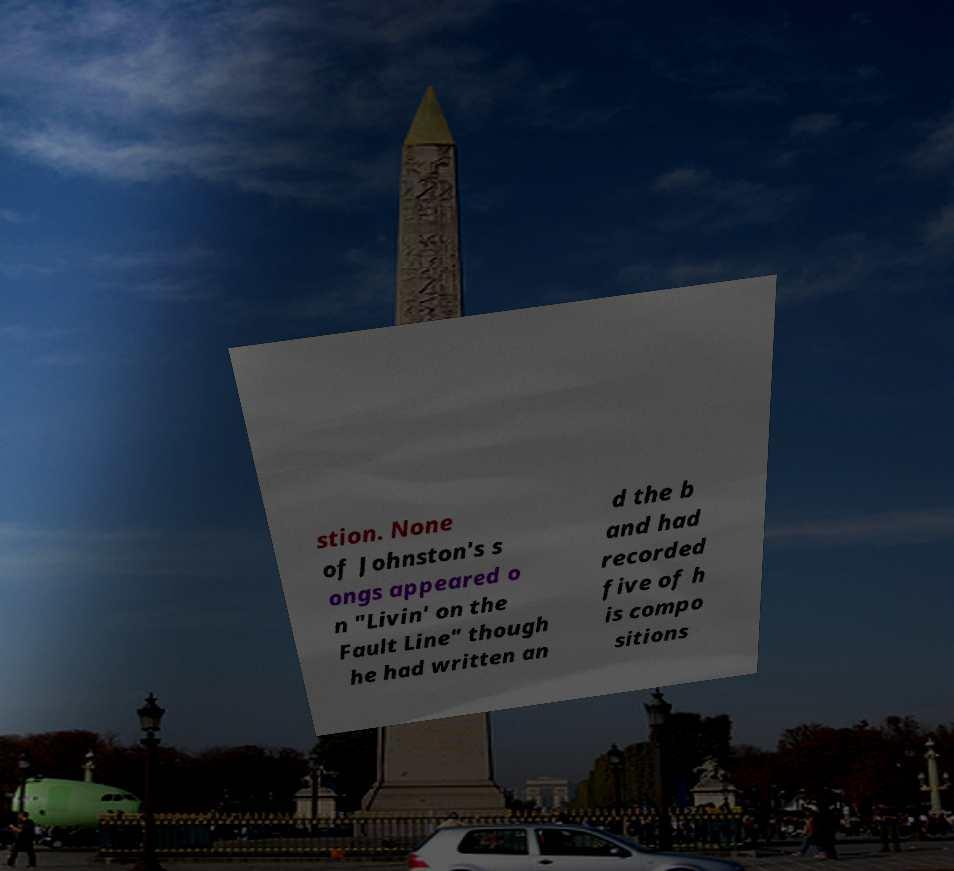There's text embedded in this image that I need extracted. Can you transcribe it verbatim? stion. None of Johnston's s ongs appeared o n "Livin' on the Fault Line" though he had written an d the b and had recorded five of h is compo sitions 